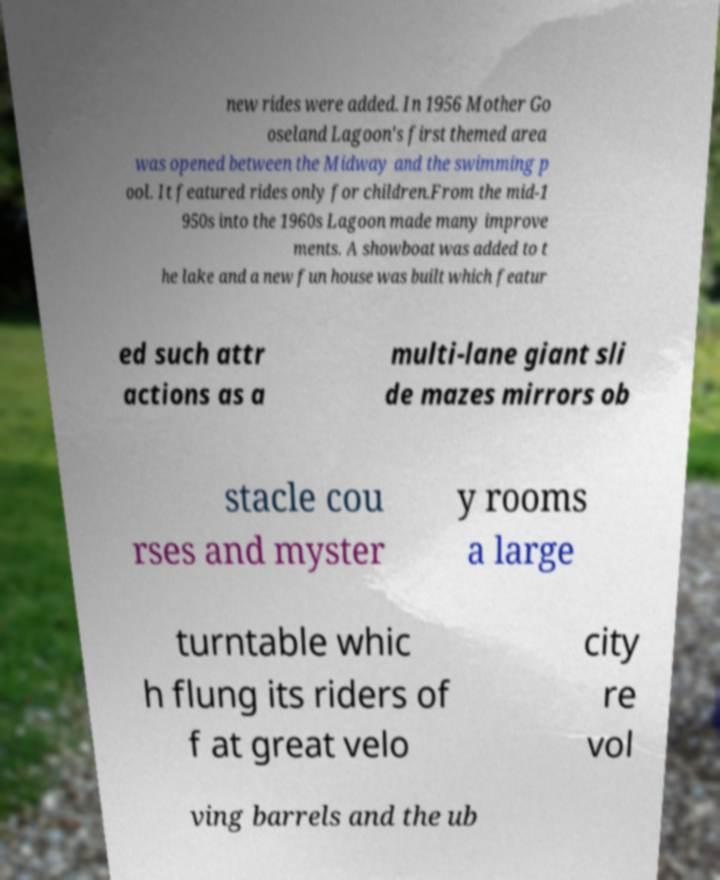There's text embedded in this image that I need extracted. Can you transcribe it verbatim? new rides were added. In 1956 Mother Go oseland Lagoon's first themed area was opened between the Midway and the swimming p ool. It featured rides only for children.From the mid-1 950s into the 1960s Lagoon made many improve ments. A showboat was added to t he lake and a new fun house was built which featur ed such attr actions as a multi-lane giant sli de mazes mirrors ob stacle cou rses and myster y rooms a large turntable whic h flung its riders of f at great velo city re vol ving barrels and the ub 